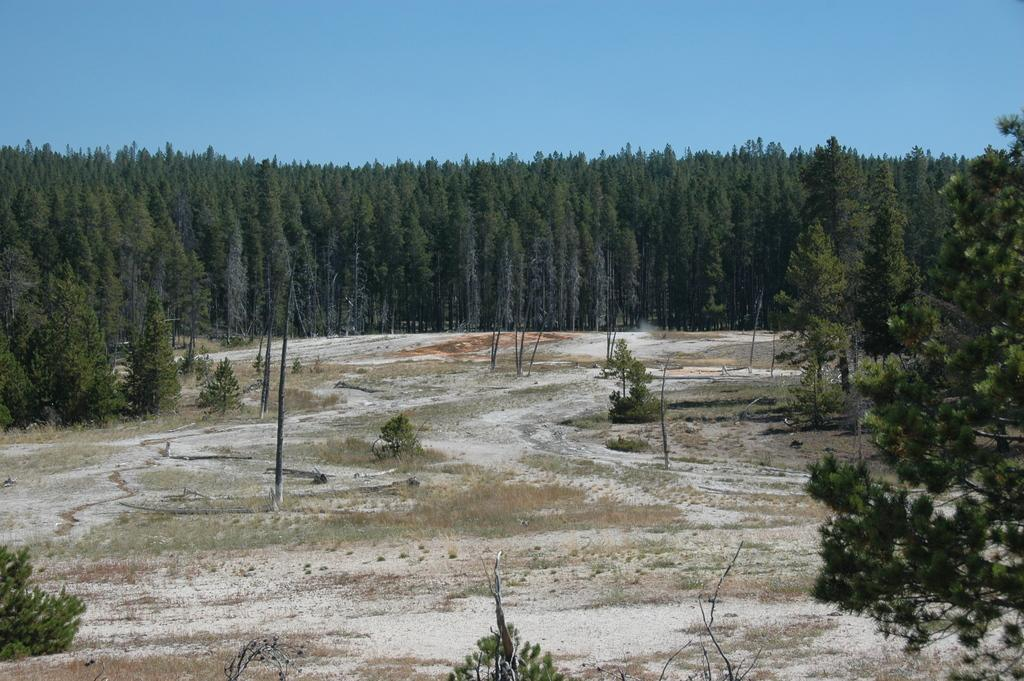What type of environment might the image be taken in? The image might be taken in a forest. What can be seen in the foreground of the picture? There are trees, plants, grass, and soil in the foreground of the picture. Are there any trees visible in the middle of the picture? Yes, there are trees in the middle of the picture. What is visible at the top of the picture? The sky is visible at the top of the picture. What type of drink is being served during recess in the image? There is no reference to a drink or recess in the image, as it features a forest scene with trees, plants, grass, soil, and the sky. 